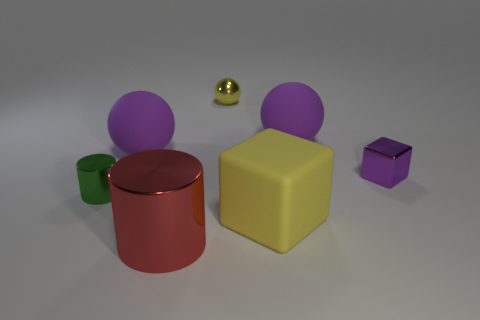Does the tiny metallic ball have the same color as the matte block?
Provide a short and direct response. Yes. Is the large red thing made of the same material as the big purple object left of the large yellow cube?
Provide a succinct answer. No. Is there any other thing that is the same color as the small shiny block?
Your answer should be very brief. Yes. There is a small shiny cube; does it have the same color as the big rubber sphere that is to the left of the large block?
Keep it short and to the point. Yes. The thing that is the same color as the shiny sphere is what size?
Your answer should be compact. Large. What is the shape of the tiny shiny object that is the same color as the large rubber cube?
Your response must be concise. Sphere. There is a small yellow ball left of the large yellow block that is right of the small yellow sphere; what is it made of?
Give a very brief answer. Metal. Is there a tiny yellow thing made of the same material as the small green thing?
Ensure brevity in your answer.  Yes. Is there a large purple matte sphere to the right of the shiny cylinder that is in front of the green shiny cylinder?
Keep it short and to the point. Yes. There is a purple thing that is on the left side of the tiny yellow thing; what is it made of?
Provide a succinct answer. Rubber. 